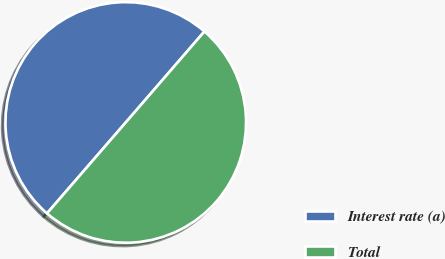<chart> <loc_0><loc_0><loc_500><loc_500><pie_chart><fcel>Interest rate (a)<fcel>Total<nl><fcel>49.99%<fcel>50.01%<nl></chart> 